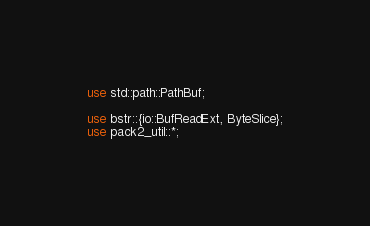Convert code to text. <code><loc_0><loc_0><loc_500><loc_500><_Rust_>use std::path::PathBuf;

use bstr::{io::BufReadExt, ByteSlice};
use pack2_util::*;
</code> 